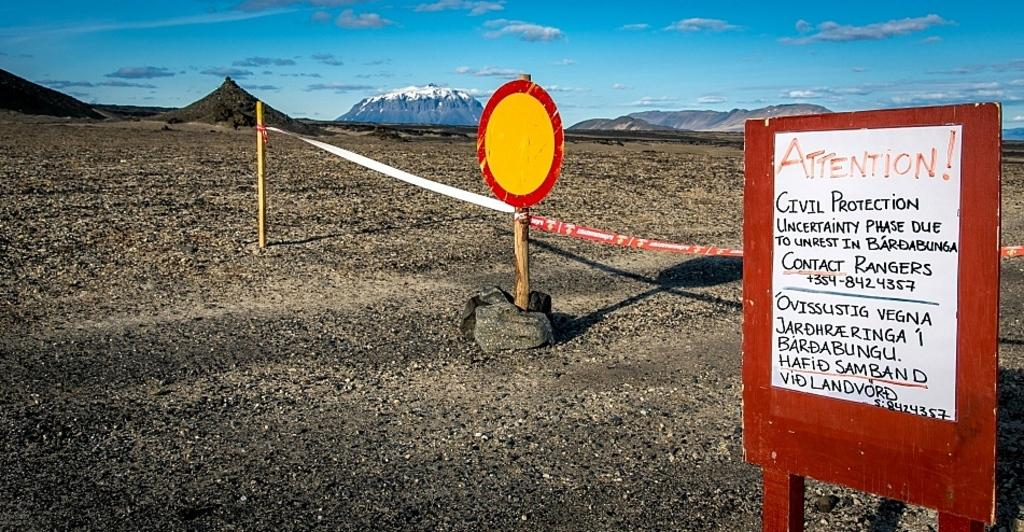<image>
Offer a succinct explanation of the picture presented. A sign has the word attention on it and warns people about an uncertainty phase due to unrest. 